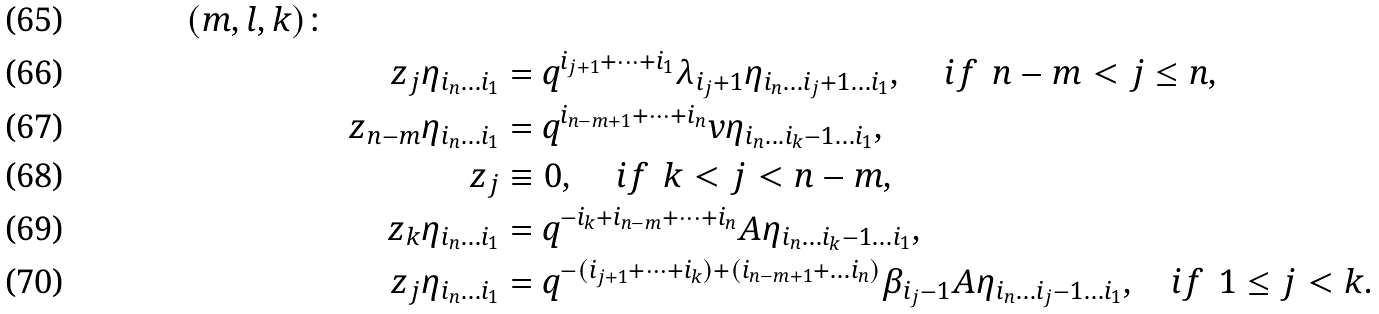Convert formula to latex. <formula><loc_0><loc_0><loc_500><loc_500>{ ( m , l , k ) \colon } \\ & & z _ { j } \eta _ { i _ { n } \dots i _ { 1 } } & = q ^ { i _ { j + 1 } + \dots + i _ { 1 } } \lambda _ { i _ { j } + 1 } \eta _ { i _ { n } \dots i _ { j } + 1 \dots i _ { 1 } } , \, \quad i f \ \, n - m < j \leq n , \\ & & z _ { n - m } \eta _ { i _ { n } \dots i _ { 1 } } & = q ^ { i _ { n - m + 1 } + \dots + i _ { n } } v \eta _ { i _ { n } \dots i _ { k } - 1 \dots i _ { 1 } } , \\ & & z _ { j } & \equiv 0 , \, \quad i f \ \, k < j < n - m , \\ & & z _ { k } \eta _ { i _ { n } \dots i _ { 1 } } & = q ^ { - i _ { k } + i _ { n - m } + \dots + i _ { n } } A \eta _ { i _ { n } \dots i _ { k } - 1 \dots i _ { 1 } } , \\ & & z _ { j } \eta _ { i _ { n } \dots i _ { 1 } } & = q ^ { - ( i _ { j + 1 } + \dots + i _ { k } ) + ( i _ { n - m + 1 } + \dots i _ { n } ) } \beta _ { i _ { j } - 1 } A \eta _ { i _ { n } \dots i _ { j } - 1 \dots i _ { 1 } } , \quad i f \ \, 1 \leq j < k .</formula> 